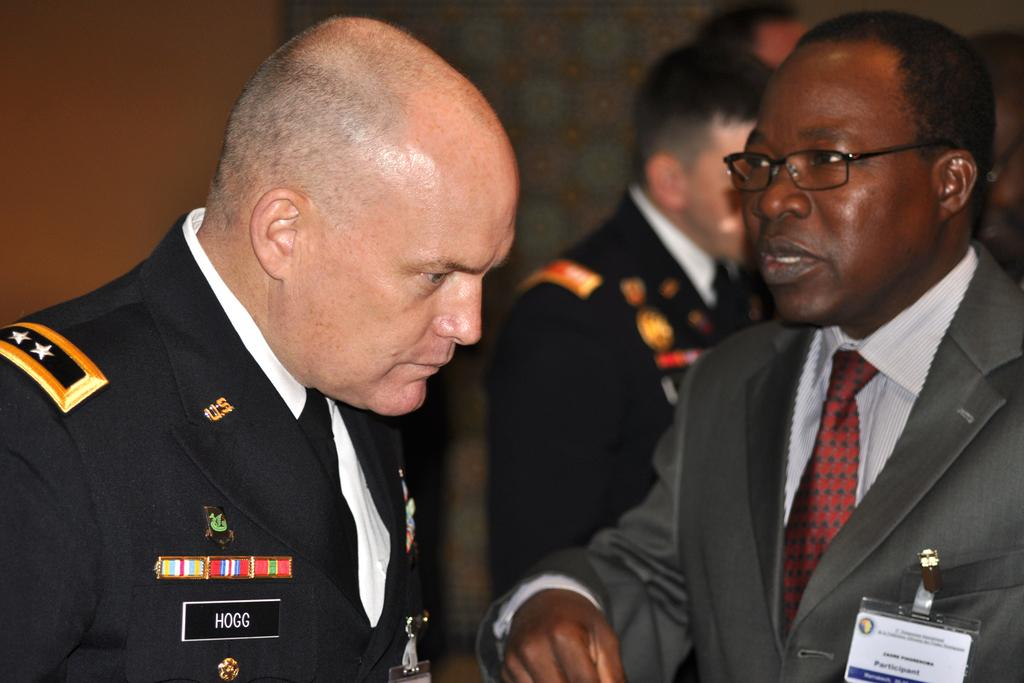How many men are in the image? There are two men in the image. What are the men wearing? Both men are wearing blazers and ties. Do the men have any identification in the image? Yes, both men have ID cards. What else can be seen in the image besides the men? There are some objects and people in the background of the image. Can you see any bats flying in the image? There are no bats visible in the image. What type of cracker is being eaten by the ants in the image? There are no ants or crackers present in the image. 